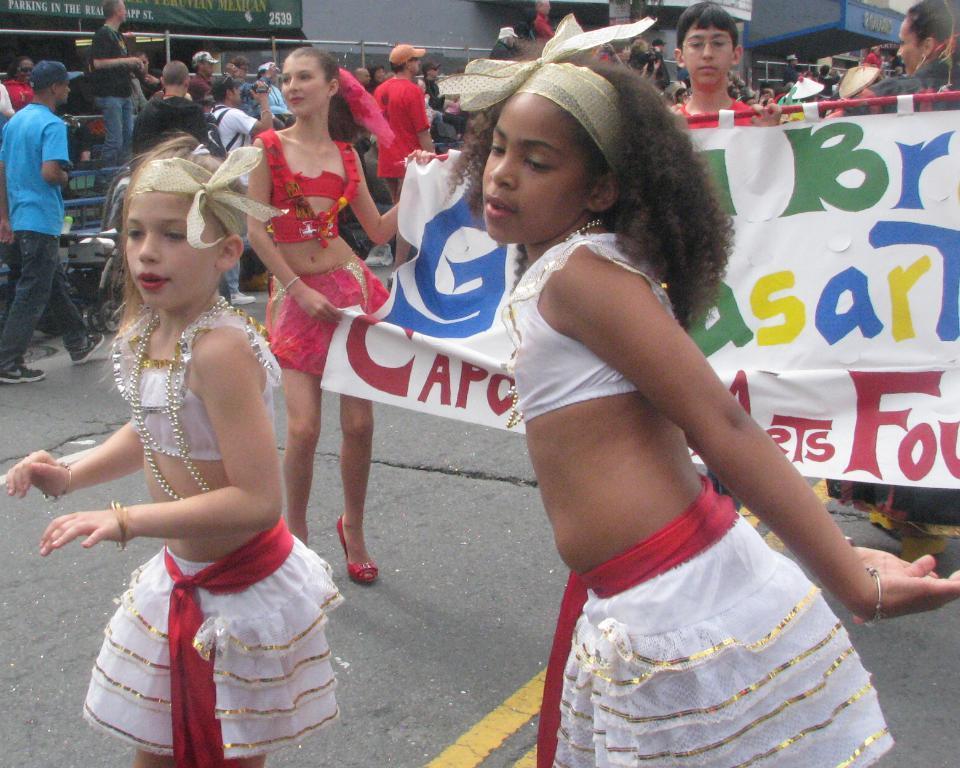In one or two sentences, can you explain what this image depicts? This picture describes about group of people, few are standing and few are walking, in the middle of the image we can see a a woman, she is holding a banner, in the background we can see few buildings and metal rods. 